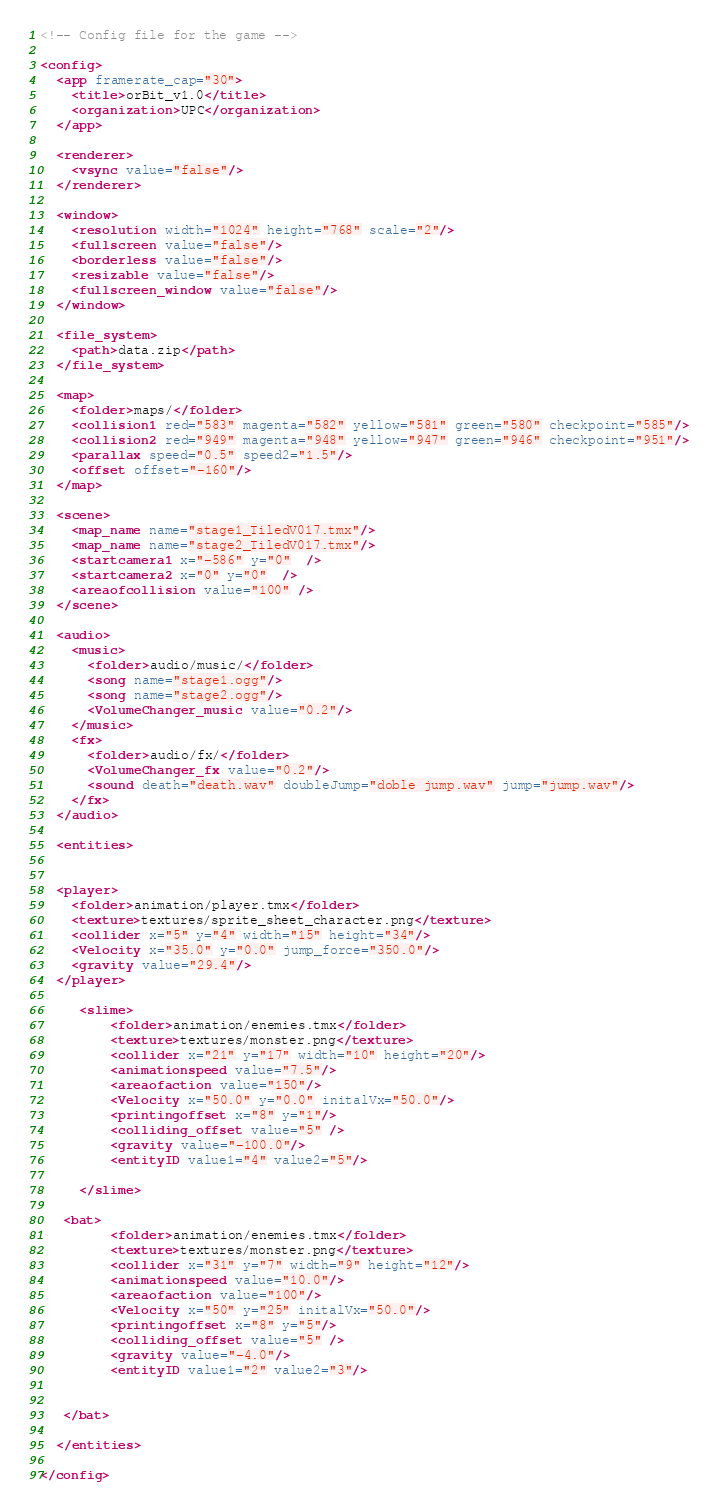<code> <loc_0><loc_0><loc_500><loc_500><_XML_><!-- Config file for the game -->

<config>
  <app framerate_cap="30">
    <title>orBit_v1.0</title>
    <organization>UPC</organization>
  </app>
	
  <renderer>
    <vsync value="false"/>
  </renderer>

  <window>
    <resolution width="1024" height="768" scale="2"/>
    <fullscreen value="false"/>
    <borderless value="false"/>
    <resizable value="false"/>
    <fullscreen_window value="false"/>
  </window>

  <file_system>
    <path>data.zip</path>
  </file_system>

  <map>
    <folder>maps/</folder>
    <collision1 red="583" magenta="582" yellow="581" green="580" checkpoint="585"/>
    <collision2 red="949" magenta="948" yellow="947" green="946" checkpoint="951"/>
    <parallax speed="0.5" speed2="1.5"/>
    <offset offset="-160"/>
  </map>

  <scene>
    <map_name name="stage1_TiledV017.tmx"/>
    <map_name name="stage2_TiledV017.tmx"/>
    <startcamera1 x="-586" y="0"  />
    <startcamera2 x="0" y="0"  />
    <areaofcollision value="100" />
  </scene>

  <audio>
    <music>
      <folder>audio/music/</folder>
      <song name="stage1.ogg"/>
      <song name="stage2.ogg"/>
      <VolumeChanger_music value="0.2"/>
    </music>
    <fx>
      <folder>audio/fx/</folder>
      <VolumeChanger_fx value="0.2"/>
      <sound death="death.wav" doubleJump="doble jump.wav" jump="jump.wav"/>
    </fx>
  </audio>

  <entities>


  <player>
    <folder>animation/player.tmx</folder>
    <texture>textures/sprite_sheet_character.png</texture>
    <collider x="5" y="4" width="15" height="34"/>
    <Velocity x="35.0" y="0.0" jump_force="350.0"/>
    <gravity value="29.4"/>
  </player>
   
     <slime>
         <folder>animation/enemies.tmx</folder>
         <texture>textures/monster.png</texture>
         <collider x="21" y="17" width="10" height="20"/>
         <animationspeed value="7.5"/>
         <areaofaction value="150"/>
         <Velocity x="50.0" y="0.0" initalVx="50.0"/>
         <printingoffset x="8" y="1"/>
         <colliding_offset value="5" />
         <gravity value="-100.0"/>
         <entityID value1="4" value2="5"/>
     
     </slime>
    
   <bat>
         <folder>animation/enemies.tmx</folder>
         <texture>textures/monster.png</texture>
         <collider x="31" y="7" width="9" height="12"/>
         <animationspeed value="10.0"/>
         <areaofaction value="100"/>
         <Velocity x="50" y="25" initalVx="50.0"/>
         <printingoffset x="8" y="5"/>
         <colliding_offset value="5" />
         <gravity value="-4.0"/>
         <entityID value1="2" value2="3"/>


   </bat>
  
  </entities>

</config></code> 